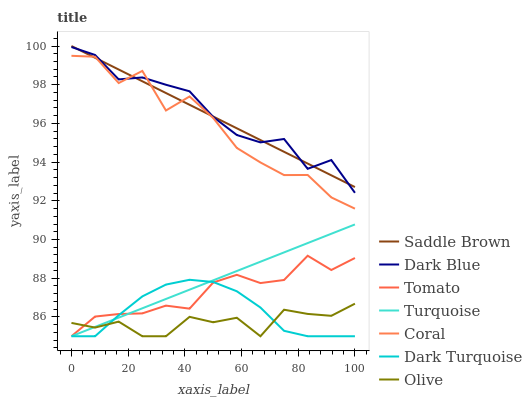Does Olive have the minimum area under the curve?
Answer yes or no. Yes. Does Dark Blue have the maximum area under the curve?
Answer yes or no. Yes. Does Turquoise have the minimum area under the curve?
Answer yes or no. No. Does Turquoise have the maximum area under the curve?
Answer yes or no. No. Is Turquoise the smoothest?
Answer yes or no. Yes. Is Coral the roughest?
Answer yes or no. Yes. Is Dark Turquoise the smoothest?
Answer yes or no. No. Is Dark Turquoise the roughest?
Answer yes or no. No. Does Tomato have the lowest value?
Answer yes or no. Yes. Does Coral have the lowest value?
Answer yes or no. No. Does Saddle Brown have the highest value?
Answer yes or no. Yes. Does Turquoise have the highest value?
Answer yes or no. No. Is Turquoise less than Saddle Brown?
Answer yes or no. Yes. Is Saddle Brown greater than Dark Turquoise?
Answer yes or no. Yes. Does Dark Turquoise intersect Olive?
Answer yes or no. Yes. Is Dark Turquoise less than Olive?
Answer yes or no. No. Is Dark Turquoise greater than Olive?
Answer yes or no. No. Does Turquoise intersect Saddle Brown?
Answer yes or no. No. 